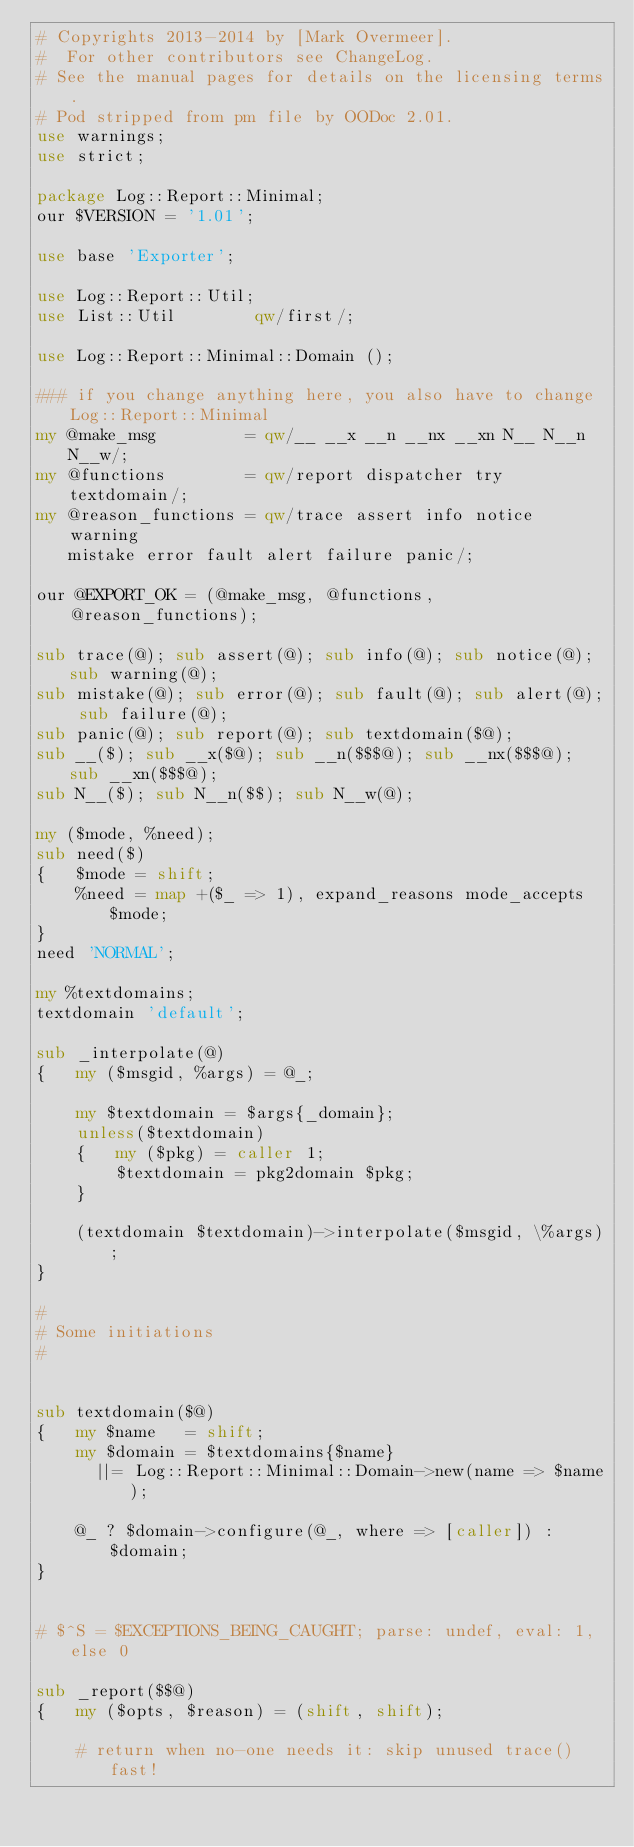<code> <loc_0><loc_0><loc_500><loc_500><_Perl_># Copyrights 2013-2014 by [Mark Overmeer].
#  For other contributors see ChangeLog.
# See the manual pages for details on the licensing terms.
# Pod stripped from pm file by OODoc 2.01.
use warnings;
use strict;

package Log::Report::Minimal;
our $VERSION = '1.01';

use base 'Exporter';

use Log::Report::Util;
use List::Util        qw/first/;

use Log::Report::Minimal::Domain ();

### if you change anything here, you also have to change Log::Report::Minimal
my @make_msg         = qw/__ __x __n __nx __xn N__ N__n N__w/;
my @functions        = qw/report dispatcher try textdomain/;
my @reason_functions = qw/trace assert info notice warning
   mistake error fault alert failure panic/;

our @EXPORT_OK = (@make_msg, @functions, @reason_functions);

sub trace(@); sub assert(@); sub info(@); sub notice(@); sub warning(@);
sub mistake(@); sub error(@); sub fault(@); sub alert(@); sub failure(@);
sub panic(@); sub report(@); sub textdomain($@);
sub __($); sub __x($@); sub __n($$$@); sub __nx($$$@); sub __xn($$$@);
sub N__($); sub N__n($$); sub N__w(@);

my ($mode, %need);
sub need($)
{   $mode = shift;
    %need = map +($_ => 1), expand_reasons mode_accepts $mode;
}
need 'NORMAL';

my %textdomains;
textdomain 'default';

sub _interpolate(@)
{   my ($msgid, %args) = @_;

    my $textdomain = $args{_domain};
    unless($textdomain)
    {   my ($pkg) = caller 1;
        $textdomain = pkg2domain $pkg;
    }

    (textdomain $textdomain)->interpolate($msgid, \%args);
}

#
# Some initiations
#


sub textdomain($@)
{   my $name   = shift;
    my $domain = $textdomains{$name}
      ||= Log::Report::Minimal::Domain->new(name => $name);

    @_ ? $domain->configure(@_, where => [caller]) : $domain;
}


# $^S = $EXCEPTIONS_BEING_CAUGHT; parse: undef, eval: 1, else 0

sub _report($$@)
{   my ($opts, $reason) = (shift, shift);

    # return when no-one needs it: skip unused trace() fast!</code> 